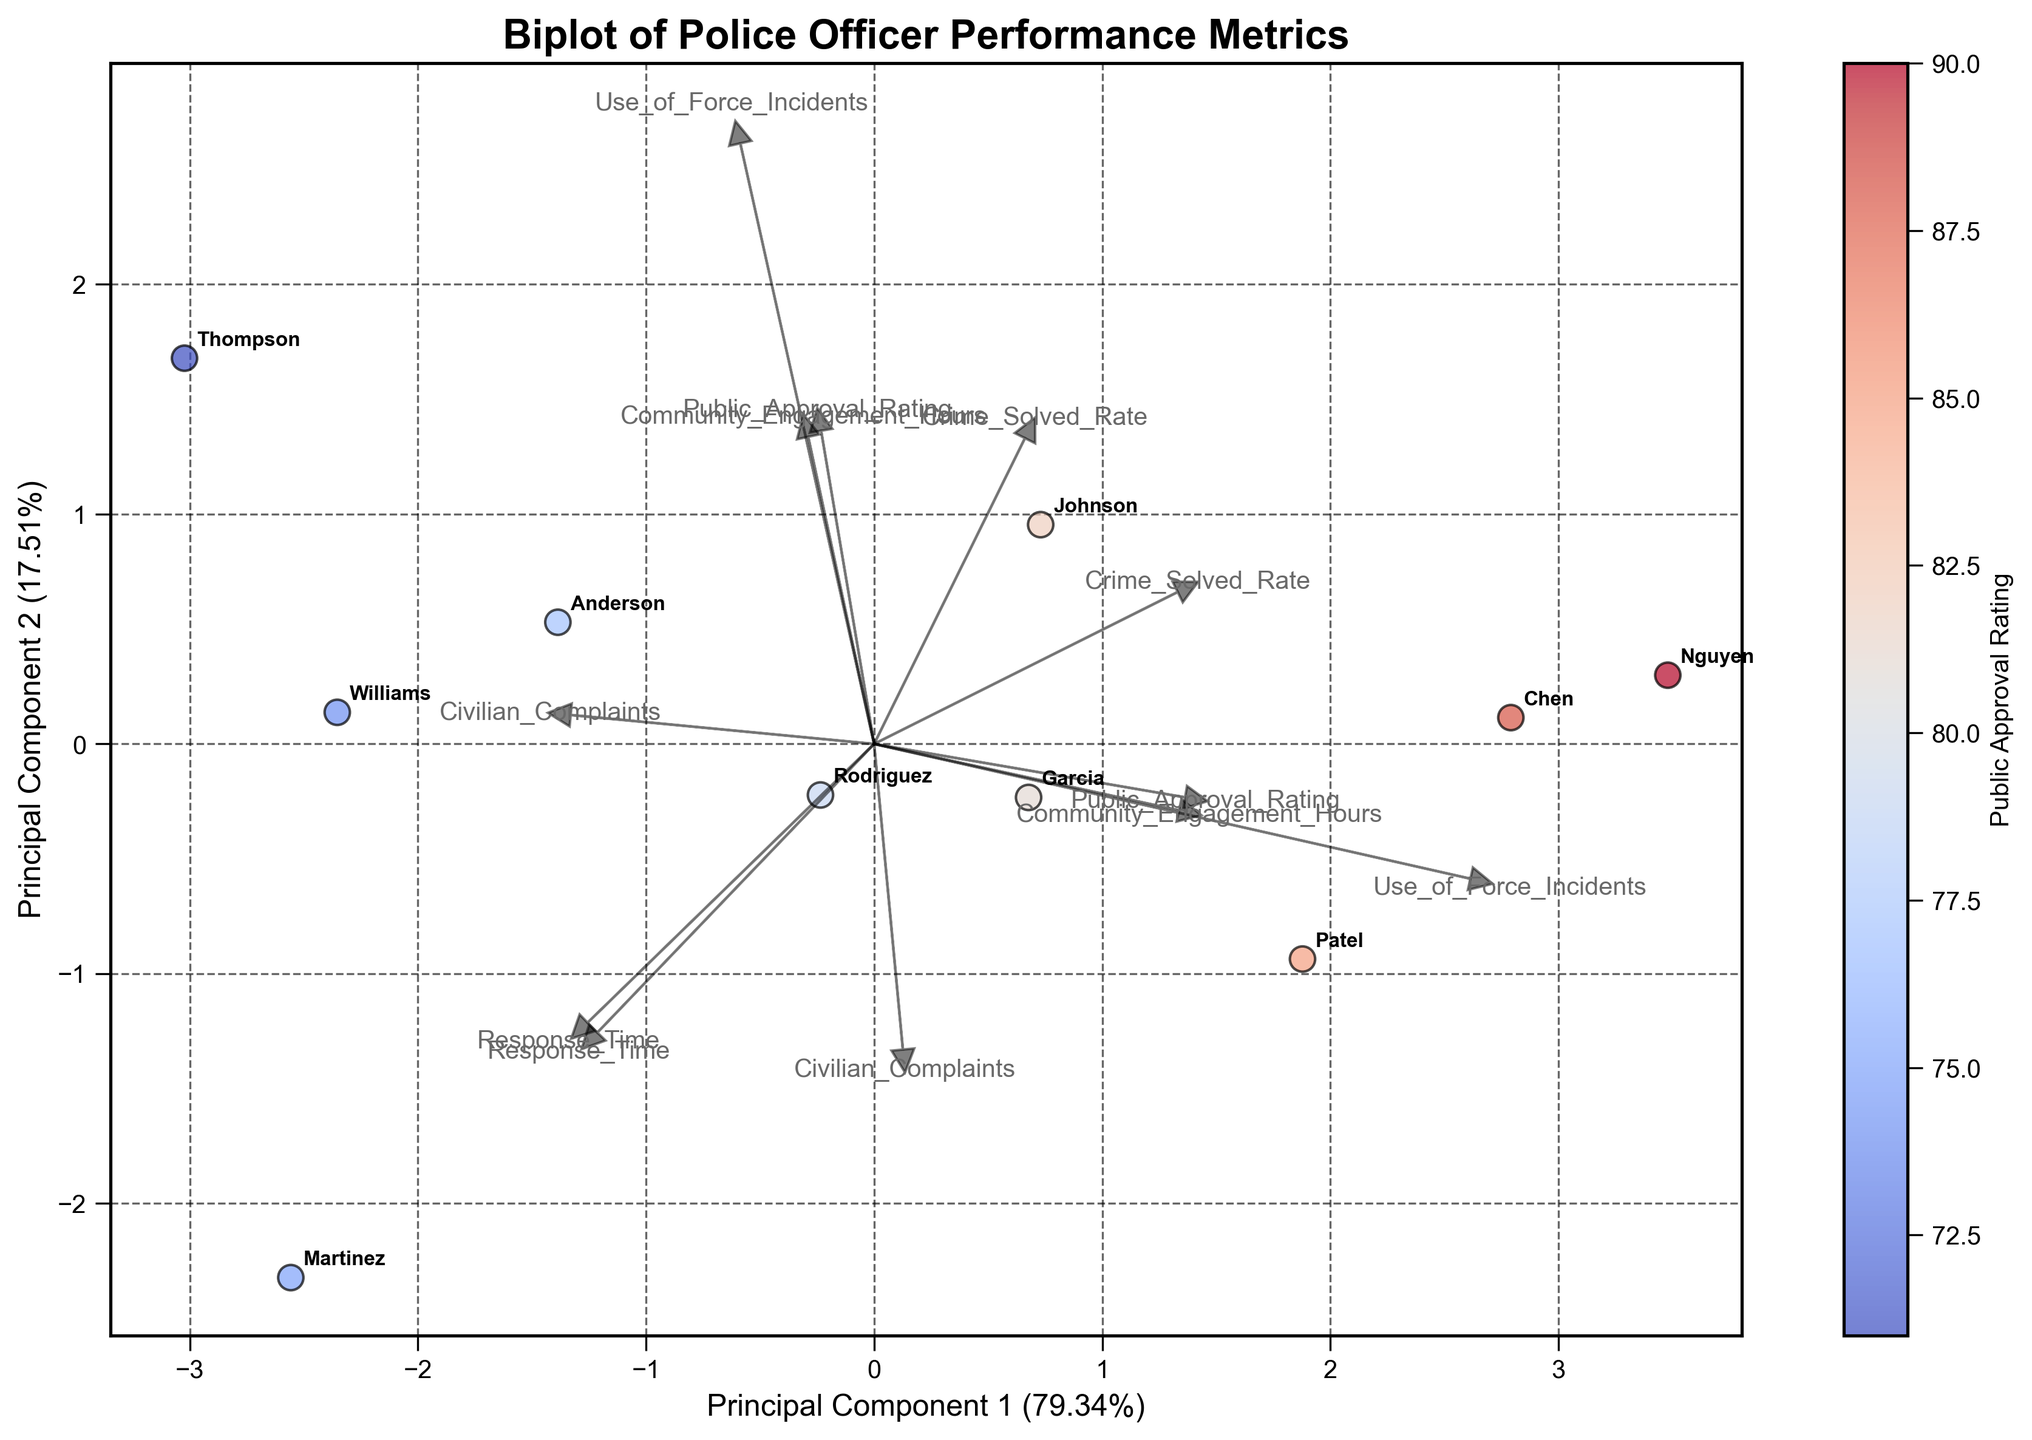What does the color scale in the figure represent? The color scale represents the 'Public Approval Rating' of each officer, with a gradient from cool to warm colors.
Answer: Public Approval Rating What do the arrows in the biplot represent? The arrows represent the six performance metrics and their directions and magnitudes indicate their influence on the two principal components.
Answer: Performance metrics influence Which officer has the highest 'Community Engagement Hours'? The officer with a vector pointing farthest in the direction of 'Community Engagement Hours' arrow has the highest value. 'Nguyen' is closest to the arrow end, indicating he has the highest.
Answer: Nguyen Which two officers are most similar based on the plot? Look for officers plotted closest to each other. 'Chen' and 'Nguyen' are closest in proximity, indicating they are most similar in performance metrics.
Answer: Chen and Nguyen How many principal components explain the variance shown in the plot? The plot uses two principal components, as indicated on the axes labeled 'Principal Component 1' and 'Principal Component 2'.
Answer: 2 Which variable has the least impact on Principal Component 1? The smallest projection length on the Principal Component 1 axis indicates least impact. 'Use_of_Force_Incidents' shows the least length.
Answer: Use_of_Force_Incidents Between 'Johnson' and 'Rodriguez,' who received fewer 'Civilian Complaints'? Johnson and Rodriguez plot positions should be aligned with the 'Civilian Complaints' arrow direction. 'Johnson' is farther from the 'Civilians Complaints' arrow, indicating fewer complaints.
Answer: Johnson Which performance metric is most closely aligned with 'Public Approval Rating'? Look at which metric arrow points in a similar direction to highest ratings colors. 'Community Engagement Hours' aligns closely with higher approval colors.
Answer: Community Engagement Hours What percentage of variance does the first principal component explain? Check the label on the x-axis indicating the percentage of variance. It is given as about 34%.
Answer: 34% What can you infer about 'Patel' based on his position in the plot? Patel is positioned in the direction of high 'Crime_Solved_Rate' and 'Community_Engagement_Hours' while being further from high 'Use_of_Force_Incidents' and 'Response_Time,' indicating better performance in these areas.
Answer: High Crime Solved and Engagement, low Use of Force & Response Time 